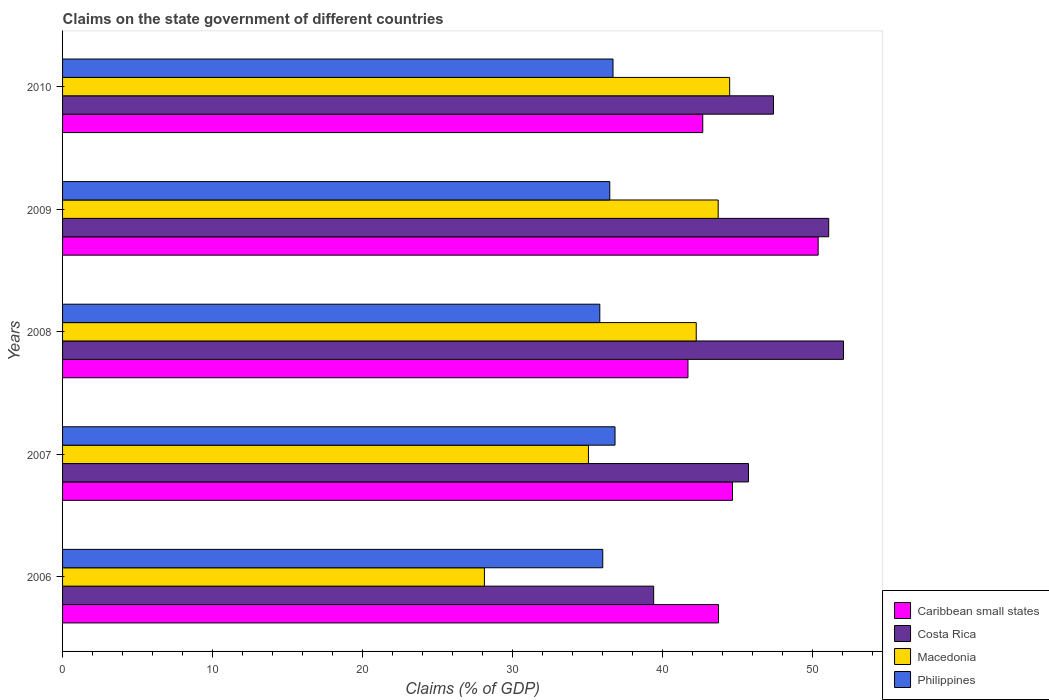How many groups of bars are there?
Make the answer very short. 5. Are the number of bars per tick equal to the number of legend labels?
Ensure brevity in your answer.  Yes. Are the number of bars on each tick of the Y-axis equal?
Your answer should be compact. Yes. How many bars are there on the 2nd tick from the top?
Provide a short and direct response. 4. How many bars are there on the 3rd tick from the bottom?
Make the answer very short. 4. What is the label of the 5th group of bars from the top?
Keep it short and to the point. 2006. In how many cases, is the number of bars for a given year not equal to the number of legend labels?
Make the answer very short. 0. What is the percentage of GDP claimed on the state government in Caribbean small states in 2009?
Your response must be concise. 50.38. Across all years, what is the maximum percentage of GDP claimed on the state government in Caribbean small states?
Provide a short and direct response. 50.38. Across all years, what is the minimum percentage of GDP claimed on the state government in Costa Rica?
Your answer should be very brief. 39.41. What is the total percentage of GDP claimed on the state government in Costa Rica in the graph?
Give a very brief answer. 235.68. What is the difference between the percentage of GDP claimed on the state government in Costa Rica in 2007 and that in 2008?
Make the answer very short. -6.33. What is the difference between the percentage of GDP claimed on the state government in Costa Rica in 2009 and the percentage of GDP claimed on the state government in Philippines in 2008?
Your response must be concise. 15.26. What is the average percentage of GDP claimed on the state government in Macedonia per year?
Give a very brief answer. 38.72. In the year 2006, what is the difference between the percentage of GDP claimed on the state government in Costa Rica and percentage of GDP claimed on the state government in Caribbean small states?
Provide a succinct answer. -4.32. In how many years, is the percentage of GDP claimed on the state government in Macedonia greater than 44 %?
Offer a very short reply. 1. What is the ratio of the percentage of GDP claimed on the state government in Costa Rica in 2008 to that in 2009?
Ensure brevity in your answer.  1.02. Is the difference between the percentage of GDP claimed on the state government in Costa Rica in 2008 and 2010 greater than the difference between the percentage of GDP claimed on the state government in Caribbean small states in 2008 and 2010?
Keep it short and to the point. Yes. What is the difference between the highest and the second highest percentage of GDP claimed on the state government in Macedonia?
Your answer should be very brief. 0.77. What is the difference between the highest and the lowest percentage of GDP claimed on the state government in Costa Rica?
Ensure brevity in your answer.  12.66. In how many years, is the percentage of GDP claimed on the state government in Costa Rica greater than the average percentage of GDP claimed on the state government in Costa Rica taken over all years?
Ensure brevity in your answer.  3. What does the 2nd bar from the top in 2006 represents?
Your answer should be compact. Macedonia. What does the 3rd bar from the bottom in 2009 represents?
Your answer should be very brief. Macedonia. How many years are there in the graph?
Make the answer very short. 5. Are the values on the major ticks of X-axis written in scientific E-notation?
Keep it short and to the point. No. Does the graph contain grids?
Provide a succinct answer. No. Where does the legend appear in the graph?
Give a very brief answer. Bottom right. What is the title of the graph?
Your answer should be compact. Claims on the state government of different countries. Does "Israel" appear as one of the legend labels in the graph?
Keep it short and to the point. No. What is the label or title of the X-axis?
Ensure brevity in your answer.  Claims (% of GDP). What is the Claims (% of GDP) of Caribbean small states in 2006?
Keep it short and to the point. 43.73. What is the Claims (% of GDP) in Costa Rica in 2006?
Offer a very short reply. 39.41. What is the Claims (% of GDP) in Macedonia in 2006?
Offer a terse response. 28.13. What is the Claims (% of GDP) in Philippines in 2006?
Make the answer very short. 36.02. What is the Claims (% of GDP) of Caribbean small states in 2007?
Keep it short and to the point. 44.67. What is the Claims (% of GDP) of Costa Rica in 2007?
Ensure brevity in your answer.  45.73. What is the Claims (% of GDP) in Macedonia in 2007?
Offer a very short reply. 35.06. What is the Claims (% of GDP) of Philippines in 2007?
Keep it short and to the point. 36.83. What is the Claims (% of GDP) in Caribbean small states in 2008?
Provide a succinct answer. 41.7. What is the Claims (% of GDP) of Costa Rica in 2008?
Give a very brief answer. 52.07. What is the Claims (% of GDP) in Macedonia in 2008?
Your response must be concise. 42.25. What is the Claims (% of GDP) of Philippines in 2008?
Offer a terse response. 35.82. What is the Claims (% of GDP) in Caribbean small states in 2009?
Provide a short and direct response. 50.38. What is the Claims (% of GDP) in Costa Rica in 2009?
Your answer should be very brief. 51.08. What is the Claims (% of GDP) in Macedonia in 2009?
Offer a very short reply. 43.71. What is the Claims (% of GDP) of Philippines in 2009?
Give a very brief answer. 36.48. What is the Claims (% of GDP) of Caribbean small states in 2010?
Offer a very short reply. 42.68. What is the Claims (% of GDP) in Costa Rica in 2010?
Your answer should be compact. 47.4. What is the Claims (% of GDP) of Macedonia in 2010?
Your response must be concise. 44.48. What is the Claims (% of GDP) of Philippines in 2010?
Provide a short and direct response. 36.7. Across all years, what is the maximum Claims (% of GDP) in Caribbean small states?
Ensure brevity in your answer.  50.38. Across all years, what is the maximum Claims (% of GDP) of Costa Rica?
Offer a very short reply. 52.07. Across all years, what is the maximum Claims (% of GDP) of Macedonia?
Provide a short and direct response. 44.48. Across all years, what is the maximum Claims (% of GDP) in Philippines?
Provide a short and direct response. 36.83. Across all years, what is the minimum Claims (% of GDP) in Caribbean small states?
Make the answer very short. 41.7. Across all years, what is the minimum Claims (% of GDP) in Costa Rica?
Your answer should be compact. 39.41. Across all years, what is the minimum Claims (% of GDP) in Macedonia?
Ensure brevity in your answer.  28.13. Across all years, what is the minimum Claims (% of GDP) of Philippines?
Ensure brevity in your answer.  35.82. What is the total Claims (% of GDP) of Caribbean small states in the graph?
Provide a succinct answer. 223.15. What is the total Claims (% of GDP) of Costa Rica in the graph?
Give a very brief answer. 235.68. What is the total Claims (% of GDP) of Macedonia in the graph?
Provide a succinct answer. 193.62. What is the total Claims (% of GDP) of Philippines in the graph?
Your answer should be compact. 181.85. What is the difference between the Claims (% of GDP) in Caribbean small states in 2006 and that in 2007?
Your answer should be compact. -0.93. What is the difference between the Claims (% of GDP) of Costa Rica in 2006 and that in 2007?
Provide a succinct answer. -6.32. What is the difference between the Claims (% of GDP) in Macedonia in 2006 and that in 2007?
Provide a short and direct response. -6.93. What is the difference between the Claims (% of GDP) of Philippines in 2006 and that in 2007?
Provide a succinct answer. -0.82. What is the difference between the Claims (% of GDP) of Caribbean small states in 2006 and that in 2008?
Give a very brief answer. 2.04. What is the difference between the Claims (% of GDP) in Costa Rica in 2006 and that in 2008?
Your response must be concise. -12.66. What is the difference between the Claims (% of GDP) in Macedonia in 2006 and that in 2008?
Offer a very short reply. -14.12. What is the difference between the Claims (% of GDP) of Philippines in 2006 and that in 2008?
Your answer should be compact. 0.2. What is the difference between the Claims (% of GDP) in Caribbean small states in 2006 and that in 2009?
Your answer should be very brief. -6.64. What is the difference between the Claims (% of GDP) in Costa Rica in 2006 and that in 2009?
Your answer should be compact. -11.67. What is the difference between the Claims (% of GDP) in Macedonia in 2006 and that in 2009?
Give a very brief answer. -15.59. What is the difference between the Claims (% of GDP) of Philippines in 2006 and that in 2009?
Provide a short and direct response. -0.47. What is the difference between the Claims (% of GDP) in Caribbean small states in 2006 and that in 2010?
Offer a very short reply. 1.05. What is the difference between the Claims (% of GDP) in Costa Rica in 2006 and that in 2010?
Offer a very short reply. -7.99. What is the difference between the Claims (% of GDP) of Macedonia in 2006 and that in 2010?
Your answer should be compact. -16.35. What is the difference between the Claims (% of GDP) of Philippines in 2006 and that in 2010?
Offer a very short reply. -0.68. What is the difference between the Claims (% of GDP) of Caribbean small states in 2007 and that in 2008?
Your answer should be very brief. 2.97. What is the difference between the Claims (% of GDP) in Costa Rica in 2007 and that in 2008?
Keep it short and to the point. -6.33. What is the difference between the Claims (% of GDP) in Macedonia in 2007 and that in 2008?
Keep it short and to the point. -7.19. What is the difference between the Claims (% of GDP) of Philippines in 2007 and that in 2008?
Provide a short and direct response. 1.01. What is the difference between the Claims (% of GDP) of Caribbean small states in 2007 and that in 2009?
Provide a short and direct response. -5.71. What is the difference between the Claims (% of GDP) in Costa Rica in 2007 and that in 2009?
Give a very brief answer. -5.35. What is the difference between the Claims (% of GDP) of Macedonia in 2007 and that in 2009?
Offer a very short reply. -8.65. What is the difference between the Claims (% of GDP) of Philippines in 2007 and that in 2009?
Ensure brevity in your answer.  0.35. What is the difference between the Claims (% of GDP) in Caribbean small states in 2007 and that in 2010?
Provide a succinct answer. 1.98. What is the difference between the Claims (% of GDP) of Costa Rica in 2007 and that in 2010?
Offer a terse response. -1.67. What is the difference between the Claims (% of GDP) of Macedonia in 2007 and that in 2010?
Your answer should be compact. -9.42. What is the difference between the Claims (% of GDP) of Philippines in 2007 and that in 2010?
Ensure brevity in your answer.  0.13. What is the difference between the Claims (% of GDP) in Caribbean small states in 2008 and that in 2009?
Make the answer very short. -8.68. What is the difference between the Claims (% of GDP) of Costa Rica in 2008 and that in 2009?
Provide a succinct answer. 0.99. What is the difference between the Claims (% of GDP) in Macedonia in 2008 and that in 2009?
Offer a terse response. -1.46. What is the difference between the Claims (% of GDP) in Philippines in 2008 and that in 2009?
Your response must be concise. -0.66. What is the difference between the Claims (% of GDP) in Caribbean small states in 2008 and that in 2010?
Ensure brevity in your answer.  -0.99. What is the difference between the Claims (% of GDP) of Costa Rica in 2008 and that in 2010?
Your answer should be very brief. 4.67. What is the difference between the Claims (% of GDP) in Macedonia in 2008 and that in 2010?
Provide a short and direct response. -2.23. What is the difference between the Claims (% of GDP) of Philippines in 2008 and that in 2010?
Give a very brief answer. -0.88. What is the difference between the Claims (% of GDP) in Caribbean small states in 2009 and that in 2010?
Provide a short and direct response. 7.69. What is the difference between the Claims (% of GDP) of Costa Rica in 2009 and that in 2010?
Provide a short and direct response. 3.68. What is the difference between the Claims (% of GDP) in Macedonia in 2009 and that in 2010?
Your answer should be very brief. -0.77. What is the difference between the Claims (% of GDP) of Philippines in 2009 and that in 2010?
Provide a succinct answer. -0.22. What is the difference between the Claims (% of GDP) of Caribbean small states in 2006 and the Claims (% of GDP) of Costa Rica in 2007?
Your answer should be compact. -2. What is the difference between the Claims (% of GDP) in Caribbean small states in 2006 and the Claims (% of GDP) in Macedonia in 2007?
Offer a terse response. 8.67. What is the difference between the Claims (% of GDP) in Caribbean small states in 2006 and the Claims (% of GDP) in Philippines in 2007?
Ensure brevity in your answer.  6.9. What is the difference between the Claims (% of GDP) of Costa Rica in 2006 and the Claims (% of GDP) of Macedonia in 2007?
Provide a succinct answer. 4.35. What is the difference between the Claims (% of GDP) of Costa Rica in 2006 and the Claims (% of GDP) of Philippines in 2007?
Provide a short and direct response. 2.58. What is the difference between the Claims (% of GDP) in Macedonia in 2006 and the Claims (% of GDP) in Philippines in 2007?
Offer a very short reply. -8.71. What is the difference between the Claims (% of GDP) in Caribbean small states in 2006 and the Claims (% of GDP) in Costa Rica in 2008?
Your answer should be very brief. -8.33. What is the difference between the Claims (% of GDP) of Caribbean small states in 2006 and the Claims (% of GDP) of Macedonia in 2008?
Your answer should be very brief. 1.49. What is the difference between the Claims (% of GDP) in Caribbean small states in 2006 and the Claims (% of GDP) in Philippines in 2008?
Your answer should be compact. 7.91. What is the difference between the Claims (% of GDP) in Costa Rica in 2006 and the Claims (% of GDP) in Macedonia in 2008?
Your answer should be very brief. -2.84. What is the difference between the Claims (% of GDP) in Costa Rica in 2006 and the Claims (% of GDP) in Philippines in 2008?
Give a very brief answer. 3.59. What is the difference between the Claims (% of GDP) in Macedonia in 2006 and the Claims (% of GDP) in Philippines in 2008?
Ensure brevity in your answer.  -7.69. What is the difference between the Claims (% of GDP) of Caribbean small states in 2006 and the Claims (% of GDP) of Costa Rica in 2009?
Your answer should be very brief. -7.35. What is the difference between the Claims (% of GDP) of Caribbean small states in 2006 and the Claims (% of GDP) of Macedonia in 2009?
Give a very brief answer. 0.02. What is the difference between the Claims (% of GDP) of Caribbean small states in 2006 and the Claims (% of GDP) of Philippines in 2009?
Your answer should be compact. 7.25. What is the difference between the Claims (% of GDP) of Costa Rica in 2006 and the Claims (% of GDP) of Macedonia in 2009?
Your answer should be very brief. -4.3. What is the difference between the Claims (% of GDP) in Costa Rica in 2006 and the Claims (% of GDP) in Philippines in 2009?
Your answer should be compact. 2.93. What is the difference between the Claims (% of GDP) of Macedonia in 2006 and the Claims (% of GDP) of Philippines in 2009?
Offer a very short reply. -8.36. What is the difference between the Claims (% of GDP) in Caribbean small states in 2006 and the Claims (% of GDP) in Costa Rica in 2010?
Make the answer very short. -3.66. What is the difference between the Claims (% of GDP) in Caribbean small states in 2006 and the Claims (% of GDP) in Macedonia in 2010?
Ensure brevity in your answer.  -0.74. What is the difference between the Claims (% of GDP) in Caribbean small states in 2006 and the Claims (% of GDP) in Philippines in 2010?
Offer a very short reply. 7.03. What is the difference between the Claims (% of GDP) of Costa Rica in 2006 and the Claims (% of GDP) of Macedonia in 2010?
Provide a short and direct response. -5.07. What is the difference between the Claims (% of GDP) in Costa Rica in 2006 and the Claims (% of GDP) in Philippines in 2010?
Ensure brevity in your answer.  2.71. What is the difference between the Claims (% of GDP) in Macedonia in 2006 and the Claims (% of GDP) in Philippines in 2010?
Provide a short and direct response. -8.57. What is the difference between the Claims (% of GDP) in Caribbean small states in 2007 and the Claims (% of GDP) in Costa Rica in 2008?
Your response must be concise. -7.4. What is the difference between the Claims (% of GDP) of Caribbean small states in 2007 and the Claims (% of GDP) of Macedonia in 2008?
Offer a very short reply. 2.42. What is the difference between the Claims (% of GDP) of Caribbean small states in 2007 and the Claims (% of GDP) of Philippines in 2008?
Provide a short and direct response. 8.85. What is the difference between the Claims (% of GDP) in Costa Rica in 2007 and the Claims (% of GDP) in Macedonia in 2008?
Offer a very short reply. 3.48. What is the difference between the Claims (% of GDP) of Costa Rica in 2007 and the Claims (% of GDP) of Philippines in 2008?
Provide a short and direct response. 9.91. What is the difference between the Claims (% of GDP) in Macedonia in 2007 and the Claims (% of GDP) in Philippines in 2008?
Provide a succinct answer. -0.76. What is the difference between the Claims (% of GDP) of Caribbean small states in 2007 and the Claims (% of GDP) of Costa Rica in 2009?
Offer a very short reply. -6.41. What is the difference between the Claims (% of GDP) in Caribbean small states in 2007 and the Claims (% of GDP) in Macedonia in 2009?
Ensure brevity in your answer.  0.95. What is the difference between the Claims (% of GDP) in Caribbean small states in 2007 and the Claims (% of GDP) in Philippines in 2009?
Your response must be concise. 8.18. What is the difference between the Claims (% of GDP) in Costa Rica in 2007 and the Claims (% of GDP) in Macedonia in 2009?
Make the answer very short. 2.02. What is the difference between the Claims (% of GDP) in Costa Rica in 2007 and the Claims (% of GDP) in Philippines in 2009?
Offer a very short reply. 9.25. What is the difference between the Claims (% of GDP) of Macedonia in 2007 and the Claims (% of GDP) of Philippines in 2009?
Give a very brief answer. -1.42. What is the difference between the Claims (% of GDP) in Caribbean small states in 2007 and the Claims (% of GDP) in Costa Rica in 2010?
Keep it short and to the point. -2.73. What is the difference between the Claims (% of GDP) in Caribbean small states in 2007 and the Claims (% of GDP) in Macedonia in 2010?
Offer a very short reply. 0.19. What is the difference between the Claims (% of GDP) in Caribbean small states in 2007 and the Claims (% of GDP) in Philippines in 2010?
Your answer should be very brief. 7.97. What is the difference between the Claims (% of GDP) of Costa Rica in 2007 and the Claims (% of GDP) of Macedonia in 2010?
Your answer should be compact. 1.25. What is the difference between the Claims (% of GDP) of Costa Rica in 2007 and the Claims (% of GDP) of Philippines in 2010?
Provide a succinct answer. 9.03. What is the difference between the Claims (% of GDP) of Macedonia in 2007 and the Claims (% of GDP) of Philippines in 2010?
Keep it short and to the point. -1.64. What is the difference between the Claims (% of GDP) in Caribbean small states in 2008 and the Claims (% of GDP) in Costa Rica in 2009?
Offer a terse response. -9.38. What is the difference between the Claims (% of GDP) of Caribbean small states in 2008 and the Claims (% of GDP) of Macedonia in 2009?
Offer a terse response. -2.01. What is the difference between the Claims (% of GDP) in Caribbean small states in 2008 and the Claims (% of GDP) in Philippines in 2009?
Make the answer very short. 5.21. What is the difference between the Claims (% of GDP) in Costa Rica in 2008 and the Claims (% of GDP) in Macedonia in 2009?
Provide a short and direct response. 8.35. What is the difference between the Claims (% of GDP) in Costa Rica in 2008 and the Claims (% of GDP) in Philippines in 2009?
Your answer should be very brief. 15.58. What is the difference between the Claims (% of GDP) of Macedonia in 2008 and the Claims (% of GDP) of Philippines in 2009?
Offer a very short reply. 5.76. What is the difference between the Claims (% of GDP) in Caribbean small states in 2008 and the Claims (% of GDP) in Costa Rica in 2010?
Offer a very short reply. -5.7. What is the difference between the Claims (% of GDP) of Caribbean small states in 2008 and the Claims (% of GDP) of Macedonia in 2010?
Your answer should be compact. -2.78. What is the difference between the Claims (% of GDP) in Caribbean small states in 2008 and the Claims (% of GDP) in Philippines in 2010?
Your answer should be compact. 5. What is the difference between the Claims (% of GDP) in Costa Rica in 2008 and the Claims (% of GDP) in Macedonia in 2010?
Offer a very short reply. 7.59. What is the difference between the Claims (% of GDP) in Costa Rica in 2008 and the Claims (% of GDP) in Philippines in 2010?
Provide a short and direct response. 15.37. What is the difference between the Claims (% of GDP) in Macedonia in 2008 and the Claims (% of GDP) in Philippines in 2010?
Offer a terse response. 5.55. What is the difference between the Claims (% of GDP) in Caribbean small states in 2009 and the Claims (% of GDP) in Costa Rica in 2010?
Offer a terse response. 2.98. What is the difference between the Claims (% of GDP) in Caribbean small states in 2009 and the Claims (% of GDP) in Macedonia in 2010?
Your answer should be very brief. 5.9. What is the difference between the Claims (% of GDP) in Caribbean small states in 2009 and the Claims (% of GDP) in Philippines in 2010?
Provide a succinct answer. 13.68. What is the difference between the Claims (% of GDP) of Costa Rica in 2009 and the Claims (% of GDP) of Macedonia in 2010?
Make the answer very short. 6.6. What is the difference between the Claims (% of GDP) in Costa Rica in 2009 and the Claims (% of GDP) in Philippines in 2010?
Offer a terse response. 14.38. What is the difference between the Claims (% of GDP) of Macedonia in 2009 and the Claims (% of GDP) of Philippines in 2010?
Give a very brief answer. 7.01. What is the average Claims (% of GDP) of Caribbean small states per year?
Make the answer very short. 44.63. What is the average Claims (% of GDP) in Costa Rica per year?
Your answer should be very brief. 47.14. What is the average Claims (% of GDP) in Macedonia per year?
Give a very brief answer. 38.72. What is the average Claims (% of GDP) in Philippines per year?
Your response must be concise. 36.37. In the year 2006, what is the difference between the Claims (% of GDP) in Caribbean small states and Claims (% of GDP) in Costa Rica?
Offer a terse response. 4.32. In the year 2006, what is the difference between the Claims (% of GDP) of Caribbean small states and Claims (% of GDP) of Macedonia?
Your response must be concise. 15.61. In the year 2006, what is the difference between the Claims (% of GDP) in Caribbean small states and Claims (% of GDP) in Philippines?
Your answer should be very brief. 7.72. In the year 2006, what is the difference between the Claims (% of GDP) in Costa Rica and Claims (% of GDP) in Macedonia?
Provide a succinct answer. 11.28. In the year 2006, what is the difference between the Claims (% of GDP) of Costa Rica and Claims (% of GDP) of Philippines?
Make the answer very short. 3.39. In the year 2006, what is the difference between the Claims (% of GDP) of Macedonia and Claims (% of GDP) of Philippines?
Make the answer very short. -7.89. In the year 2007, what is the difference between the Claims (% of GDP) of Caribbean small states and Claims (% of GDP) of Costa Rica?
Keep it short and to the point. -1.07. In the year 2007, what is the difference between the Claims (% of GDP) of Caribbean small states and Claims (% of GDP) of Macedonia?
Your answer should be compact. 9.61. In the year 2007, what is the difference between the Claims (% of GDP) in Caribbean small states and Claims (% of GDP) in Philippines?
Your answer should be very brief. 7.83. In the year 2007, what is the difference between the Claims (% of GDP) in Costa Rica and Claims (% of GDP) in Macedonia?
Your answer should be very brief. 10.67. In the year 2007, what is the difference between the Claims (% of GDP) in Costa Rica and Claims (% of GDP) in Philippines?
Your response must be concise. 8.9. In the year 2007, what is the difference between the Claims (% of GDP) of Macedonia and Claims (% of GDP) of Philippines?
Make the answer very short. -1.77. In the year 2008, what is the difference between the Claims (% of GDP) of Caribbean small states and Claims (% of GDP) of Costa Rica?
Offer a terse response. -10.37. In the year 2008, what is the difference between the Claims (% of GDP) of Caribbean small states and Claims (% of GDP) of Macedonia?
Provide a succinct answer. -0.55. In the year 2008, what is the difference between the Claims (% of GDP) of Caribbean small states and Claims (% of GDP) of Philippines?
Keep it short and to the point. 5.88. In the year 2008, what is the difference between the Claims (% of GDP) of Costa Rica and Claims (% of GDP) of Macedonia?
Keep it short and to the point. 9.82. In the year 2008, what is the difference between the Claims (% of GDP) in Costa Rica and Claims (% of GDP) in Philippines?
Your answer should be very brief. 16.25. In the year 2008, what is the difference between the Claims (% of GDP) of Macedonia and Claims (% of GDP) of Philippines?
Make the answer very short. 6.43. In the year 2009, what is the difference between the Claims (% of GDP) of Caribbean small states and Claims (% of GDP) of Costa Rica?
Give a very brief answer. -0.7. In the year 2009, what is the difference between the Claims (% of GDP) of Caribbean small states and Claims (% of GDP) of Macedonia?
Your answer should be very brief. 6.67. In the year 2009, what is the difference between the Claims (% of GDP) in Caribbean small states and Claims (% of GDP) in Philippines?
Your answer should be very brief. 13.89. In the year 2009, what is the difference between the Claims (% of GDP) in Costa Rica and Claims (% of GDP) in Macedonia?
Make the answer very short. 7.37. In the year 2009, what is the difference between the Claims (% of GDP) of Costa Rica and Claims (% of GDP) of Philippines?
Give a very brief answer. 14.6. In the year 2009, what is the difference between the Claims (% of GDP) in Macedonia and Claims (% of GDP) in Philippines?
Provide a succinct answer. 7.23. In the year 2010, what is the difference between the Claims (% of GDP) in Caribbean small states and Claims (% of GDP) in Costa Rica?
Make the answer very short. -4.71. In the year 2010, what is the difference between the Claims (% of GDP) of Caribbean small states and Claims (% of GDP) of Macedonia?
Keep it short and to the point. -1.79. In the year 2010, what is the difference between the Claims (% of GDP) in Caribbean small states and Claims (% of GDP) in Philippines?
Provide a short and direct response. 5.98. In the year 2010, what is the difference between the Claims (% of GDP) in Costa Rica and Claims (% of GDP) in Macedonia?
Make the answer very short. 2.92. In the year 2010, what is the difference between the Claims (% of GDP) of Costa Rica and Claims (% of GDP) of Philippines?
Offer a very short reply. 10.7. In the year 2010, what is the difference between the Claims (% of GDP) in Macedonia and Claims (% of GDP) in Philippines?
Keep it short and to the point. 7.78. What is the ratio of the Claims (% of GDP) of Caribbean small states in 2006 to that in 2007?
Ensure brevity in your answer.  0.98. What is the ratio of the Claims (% of GDP) in Costa Rica in 2006 to that in 2007?
Ensure brevity in your answer.  0.86. What is the ratio of the Claims (% of GDP) in Macedonia in 2006 to that in 2007?
Keep it short and to the point. 0.8. What is the ratio of the Claims (% of GDP) of Philippines in 2006 to that in 2007?
Your answer should be very brief. 0.98. What is the ratio of the Claims (% of GDP) of Caribbean small states in 2006 to that in 2008?
Offer a terse response. 1.05. What is the ratio of the Claims (% of GDP) in Costa Rica in 2006 to that in 2008?
Provide a short and direct response. 0.76. What is the ratio of the Claims (% of GDP) in Macedonia in 2006 to that in 2008?
Offer a very short reply. 0.67. What is the ratio of the Claims (% of GDP) of Philippines in 2006 to that in 2008?
Offer a very short reply. 1.01. What is the ratio of the Claims (% of GDP) in Caribbean small states in 2006 to that in 2009?
Your answer should be very brief. 0.87. What is the ratio of the Claims (% of GDP) in Costa Rica in 2006 to that in 2009?
Provide a succinct answer. 0.77. What is the ratio of the Claims (% of GDP) in Macedonia in 2006 to that in 2009?
Give a very brief answer. 0.64. What is the ratio of the Claims (% of GDP) of Philippines in 2006 to that in 2009?
Ensure brevity in your answer.  0.99. What is the ratio of the Claims (% of GDP) of Caribbean small states in 2006 to that in 2010?
Provide a short and direct response. 1.02. What is the ratio of the Claims (% of GDP) in Costa Rica in 2006 to that in 2010?
Offer a very short reply. 0.83. What is the ratio of the Claims (% of GDP) in Macedonia in 2006 to that in 2010?
Ensure brevity in your answer.  0.63. What is the ratio of the Claims (% of GDP) of Philippines in 2006 to that in 2010?
Your answer should be very brief. 0.98. What is the ratio of the Claims (% of GDP) in Caribbean small states in 2007 to that in 2008?
Give a very brief answer. 1.07. What is the ratio of the Claims (% of GDP) in Costa Rica in 2007 to that in 2008?
Provide a short and direct response. 0.88. What is the ratio of the Claims (% of GDP) of Macedonia in 2007 to that in 2008?
Provide a succinct answer. 0.83. What is the ratio of the Claims (% of GDP) in Philippines in 2007 to that in 2008?
Keep it short and to the point. 1.03. What is the ratio of the Claims (% of GDP) of Caribbean small states in 2007 to that in 2009?
Give a very brief answer. 0.89. What is the ratio of the Claims (% of GDP) in Costa Rica in 2007 to that in 2009?
Offer a terse response. 0.9. What is the ratio of the Claims (% of GDP) of Macedonia in 2007 to that in 2009?
Offer a very short reply. 0.8. What is the ratio of the Claims (% of GDP) of Philippines in 2007 to that in 2009?
Offer a very short reply. 1.01. What is the ratio of the Claims (% of GDP) in Caribbean small states in 2007 to that in 2010?
Provide a succinct answer. 1.05. What is the ratio of the Claims (% of GDP) of Costa Rica in 2007 to that in 2010?
Keep it short and to the point. 0.96. What is the ratio of the Claims (% of GDP) in Macedonia in 2007 to that in 2010?
Provide a succinct answer. 0.79. What is the ratio of the Claims (% of GDP) of Philippines in 2007 to that in 2010?
Your answer should be compact. 1. What is the ratio of the Claims (% of GDP) of Caribbean small states in 2008 to that in 2009?
Your answer should be compact. 0.83. What is the ratio of the Claims (% of GDP) in Costa Rica in 2008 to that in 2009?
Offer a very short reply. 1.02. What is the ratio of the Claims (% of GDP) in Macedonia in 2008 to that in 2009?
Offer a very short reply. 0.97. What is the ratio of the Claims (% of GDP) of Philippines in 2008 to that in 2009?
Offer a terse response. 0.98. What is the ratio of the Claims (% of GDP) of Caribbean small states in 2008 to that in 2010?
Your answer should be compact. 0.98. What is the ratio of the Claims (% of GDP) of Costa Rica in 2008 to that in 2010?
Your response must be concise. 1.1. What is the ratio of the Claims (% of GDP) of Macedonia in 2008 to that in 2010?
Your answer should be compact. 0.95. What is the ratio of the Claims (% of GDP) in Philippines in 2008 to that in 2010?
Your answer should be compact. 0.98. What is the ratio of the Claims (% of GDP) of Caribbean small states in 2009 to that in 2010?
Your answer should be very brief. 1.18. What is the ratio of the Claims (% of GDP) in Costa Rica in 2009 to that in 2010?
Make the answer very short. 1.08. What is the ratio of the Claims (% of GDP) in Macedonia in 2009 to that in 2010?
Provide a short and direct response. 0.98. What is the ratio of the Claims (% of GDP) of Philippines in 2009 to that in 2010?
Ensure brevity in your answer.  0.99. What is the difference between the highest and the second highest Claims (% of GDP) of Caribbean small states?
Keep it short and to the point. 5.71. What is the difference between the highest and the second highest Claims (% of GDP) in Costa Rica?
Your answer should be compact. 0.99. What is the difference between the highest and the second highest Claims (% of GDP) of Macedonia?
Keep it short and to the point. 0.77. What is the difference between the highest and the second highest Claims (% of GDP) of Philippines?
Make the answer very short. 0.13. What is the difference between the highest and the lowest Claims (% of GDP) in Caribbean small states?
Ensure brevity in your answer.  8.68. What is the difference between the highest and the lowest Claims (% of GDP) in Costa Rica?
Your response must be concise. 12.66. What is the difference between the highest and the lowest Claims (% of GDP) in Macedonia?
Provide a succinct answer. 16.35. What is the difference between the highest and the lowest Claims (% of GDP) of Philippines?
Your response must be concise. 1.01. 